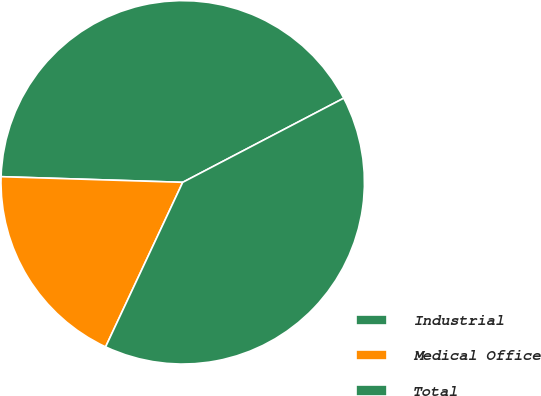Convert chart to OTSL. <chart><loc_0><loc_0><loc_500><loc_500><pie_chart><fcel>Industrial<fcel>Medical Office<fcel>Total<nl><fcel>41.84%<fcel>18.52%<fcel>39.64%<nl></chart> 